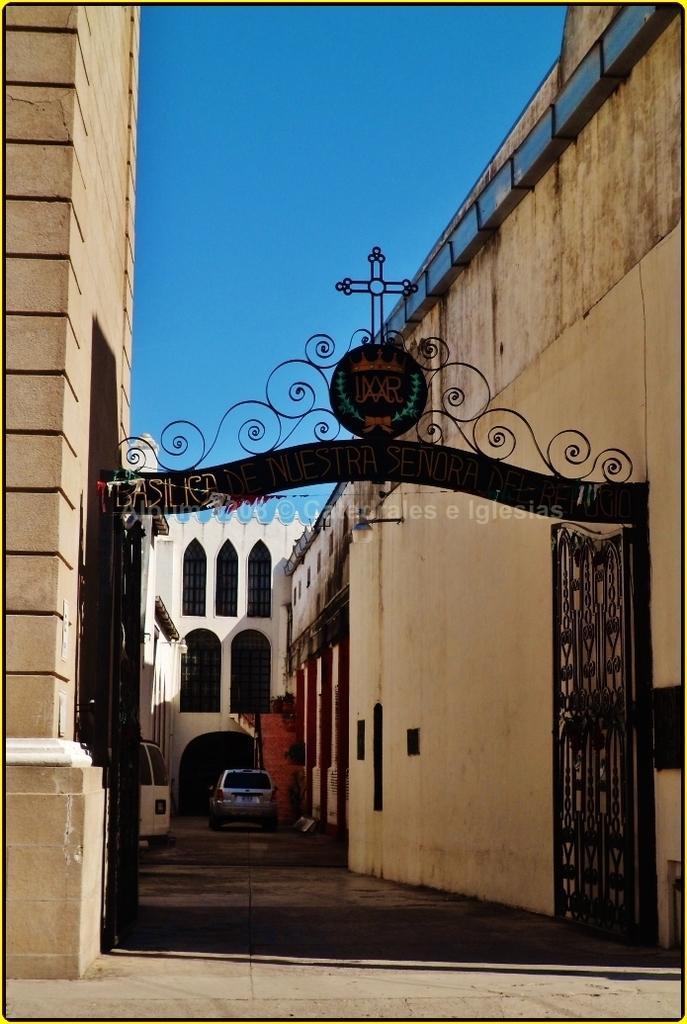Describe this image in one or two sentences. In this image we can see gates with an arch. On the arch there is a cross. On the sides there are walls. In the back there is a car. Also there is a building with arches. In the background there is sky. 